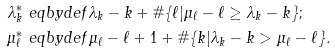<formula> <loc_0><loc_0><loc_500><loc_500>\lambda ^ { * } _ { k } & \ e q b y d e f \lambda _ { k } - k + \# \{ \ell | \mu _ { \ell } - \ell \geq \lambda _ { k } - k \} ; \\ \mu ^ { * } _ { \ell } & \ e q b y d e f \mu _ { \ell } - \ell + 1 + \# \{ k | \lambda _ { k } - k > \mu _ { \ell } - \ell \} .</formula> 